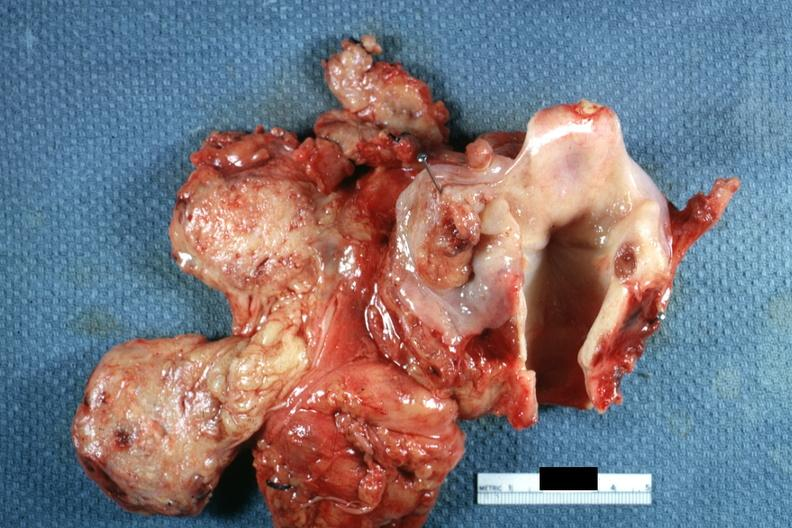what is present?
Answer the question using a single word or phrase. Hypopharynx 